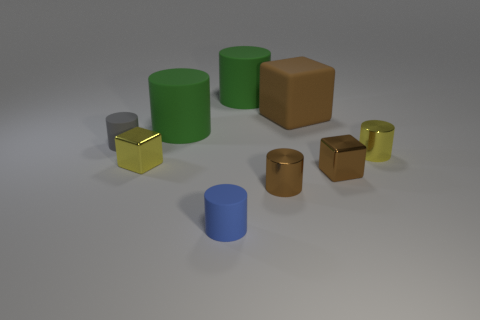Subtract all brown cylinders. How many cylinders are left? 5 Subtract all small matte cylinders. How many cylinders are left? 4 Subtract all purple cylinders. Subtract all gray blocks. How many cylinders are left? 6 Subtract all blocks. How many objects are left? 6 Add 5 brown rubber objects. How many brown rubber objects are left? 6 Add 1 large purple rubber cylinders. How many large purple rubber cylinders exist? 1 Subtract 1 yellow cylinders. How many objects are left? 8 Subtract all large brown matte blocks. Subtract all brown things. How many objects are left? 5 